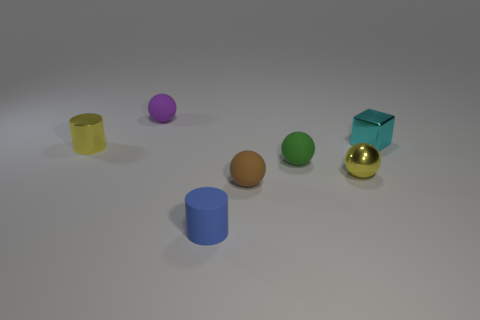Subtract all green balls. How many balls are left? 3 Subtract all red spheres. Subtract all blue cubes. How many spheres are left? 4 Add 1 green matte objects. How many objects exist? 8 Subtract all balls. How many objects are left? 3 Add 4 brown balls. How many brown balls are left? 5 Add 4 small cyan matte balls. How many small cyan matte balls exist? 4 Subtract 0 red cylinders. How many objects are left? 7 Subtract all small purple rubber objects. Subtract all tiny blue balls. How many objects are left? 6 